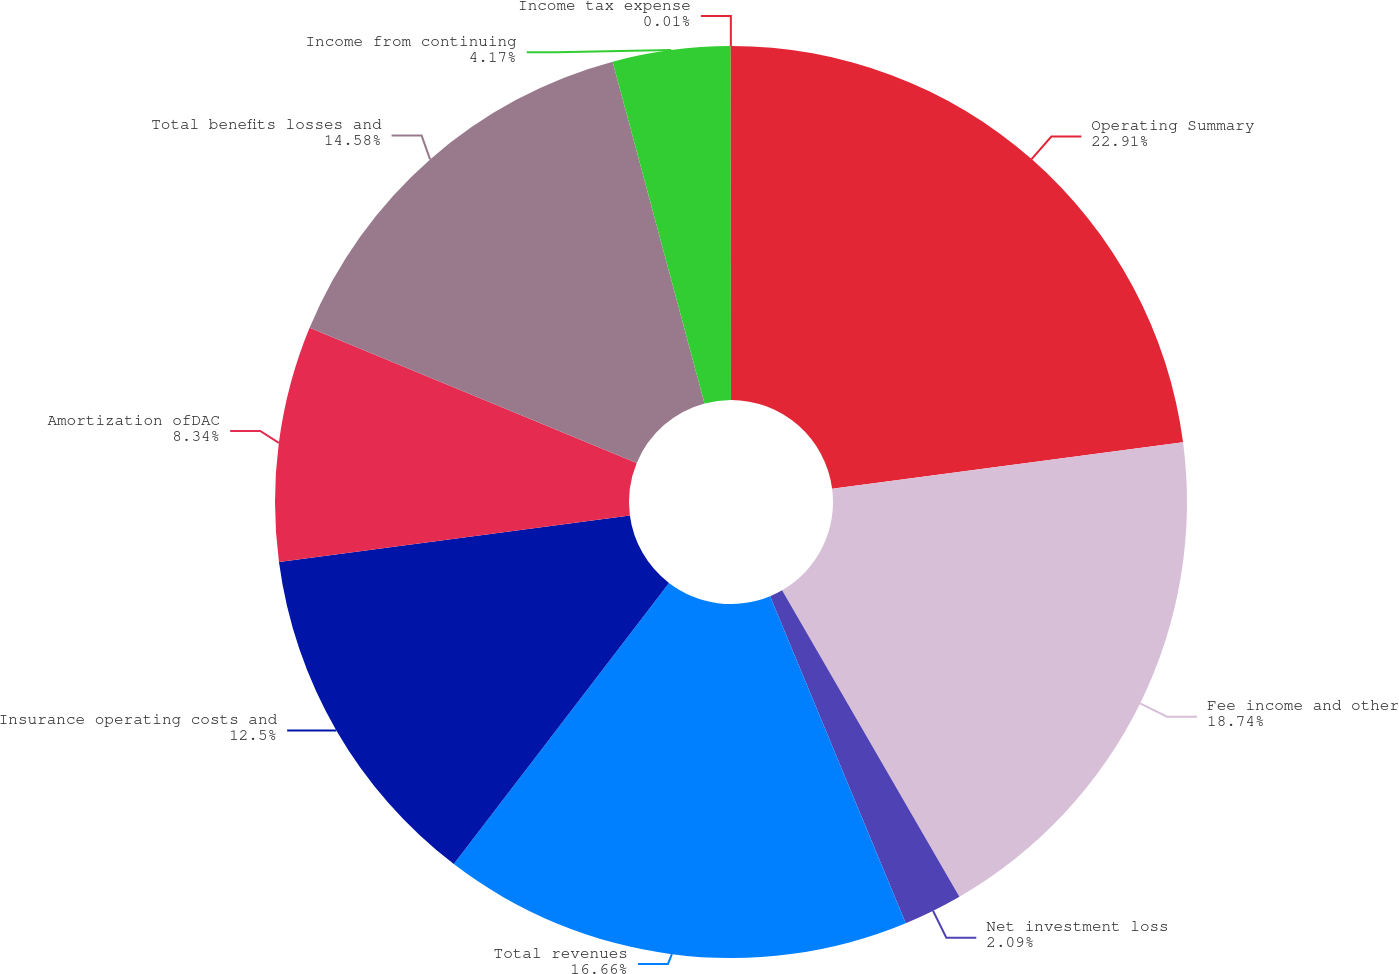<chart> <loc_0><loc_0><loc_500><loc_500><pie_chart><fcel>Operating Summary<fcel>Fee income and other<fcel>Net investment loss<fcel>Total revenues<fcel>Insurance operating costs and<fcel>Amortization ofDAC<fcel>Total benefits losses and<fcel>Income from continuing<fcel>Income tax expense<nl><fcel>22.91%<fcel>18.74%<fcel>2.09%<fcel>16.66%<fcel>12.5%<fcel>8.34%<fcel>14.58%<fcel>4.17%<fcel>0.01%<nl></chart> 